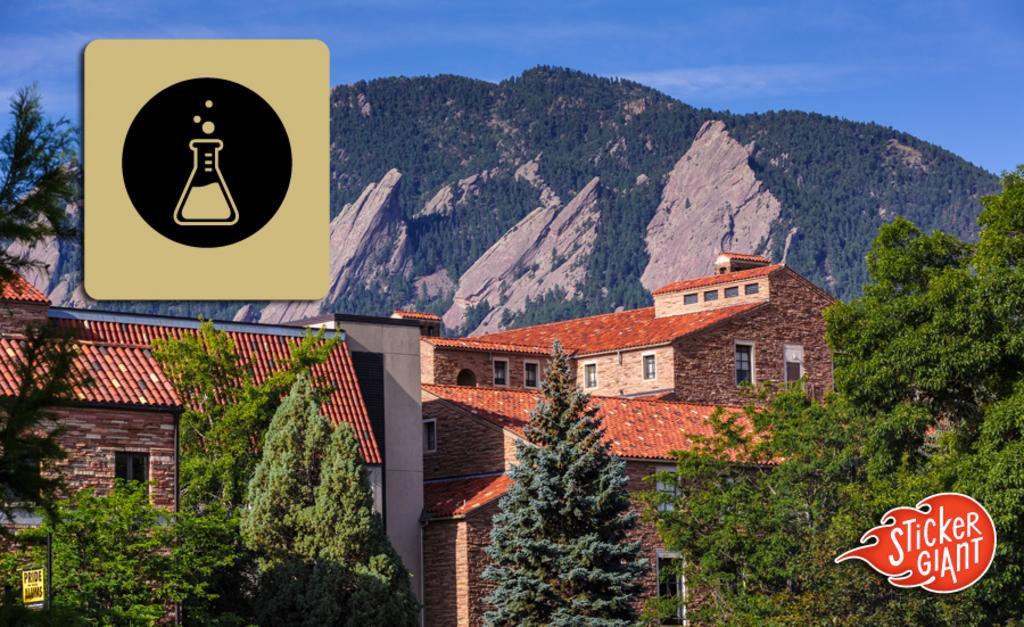Can you describe this image briefly? In this image there are trees, buildings, a board attached to the pole, hills, sky , watermarks on the image. 